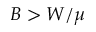<formula> <loc_0><loc_0><loc_500><loc_500>B > W / \mu</formula> 